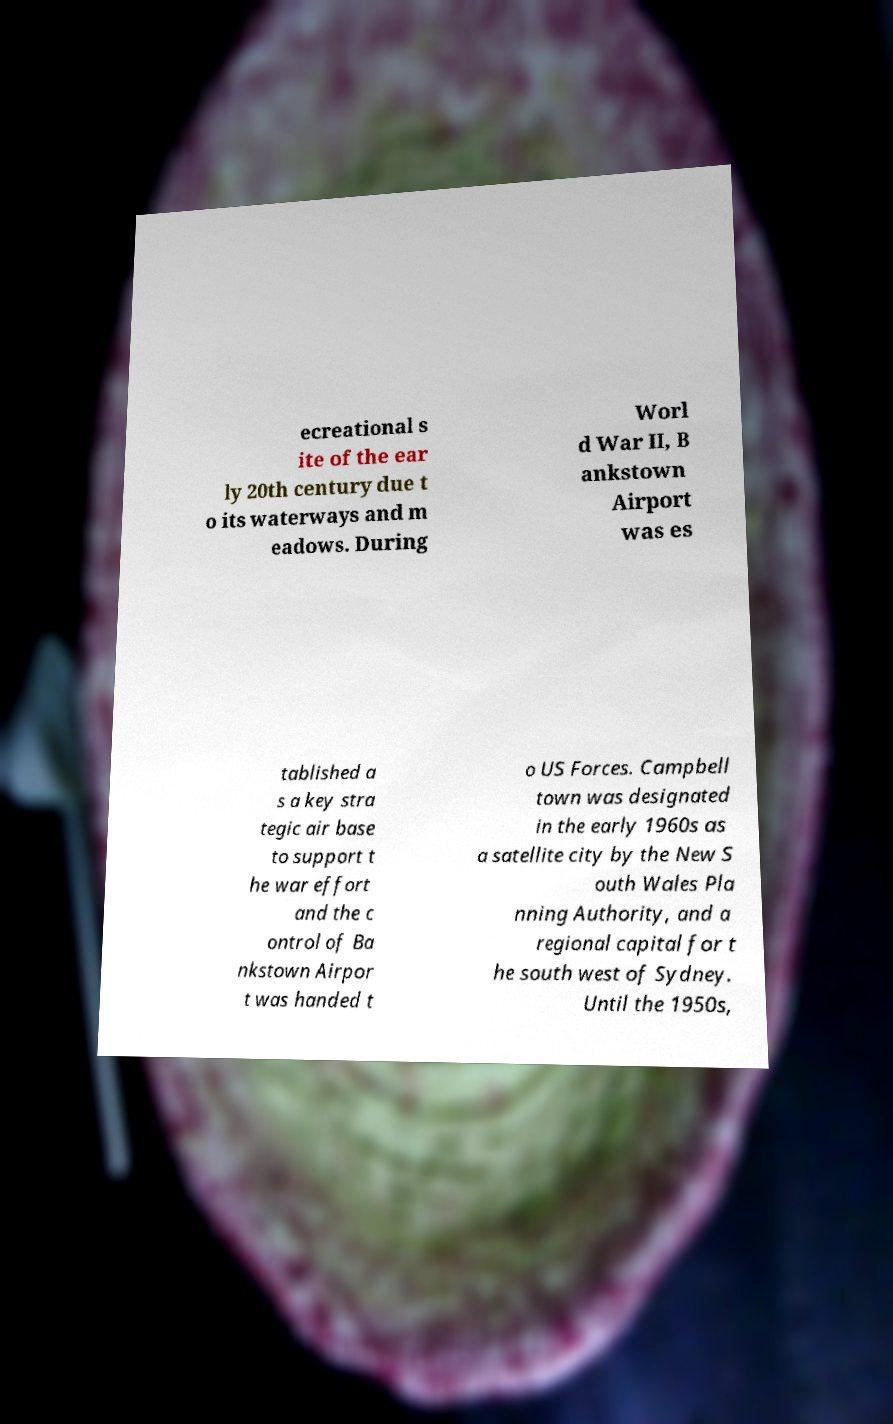What messages or text are displayed in this image? I need them in a readable, typed format. ecreational s ite of the ear ly 20th century due t o its waterways and m eadows. During Worl d War II, B ankstown Airport was es tablished a s a key stra tegic air base to support t he war effort and the c ontrol of Ba nkstown Airpor t was handed t o US Forces. Campbell town was designated in the early 1960s as a satellite city by the New S outh Wales Pla nning Authority, and a regional capital for t he south west of Sydney. Until the 1950s, 